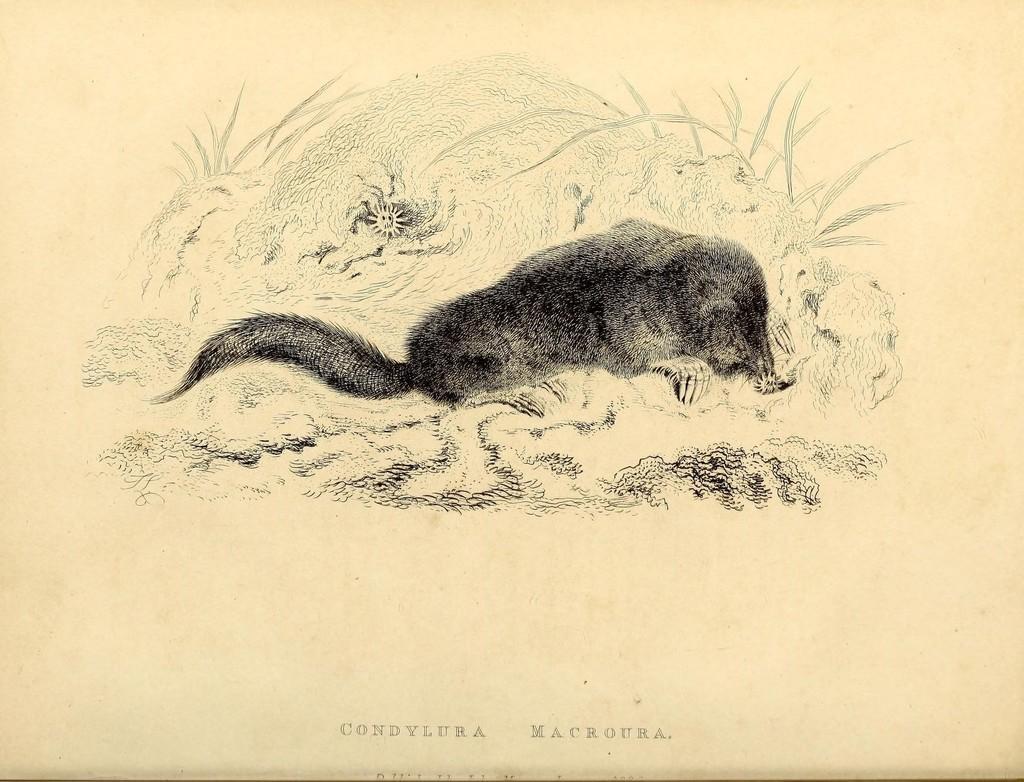How would you summarize this image in a sentence or two? In this image there is a drawing in that there is an animal, at the bottom there is some text. 